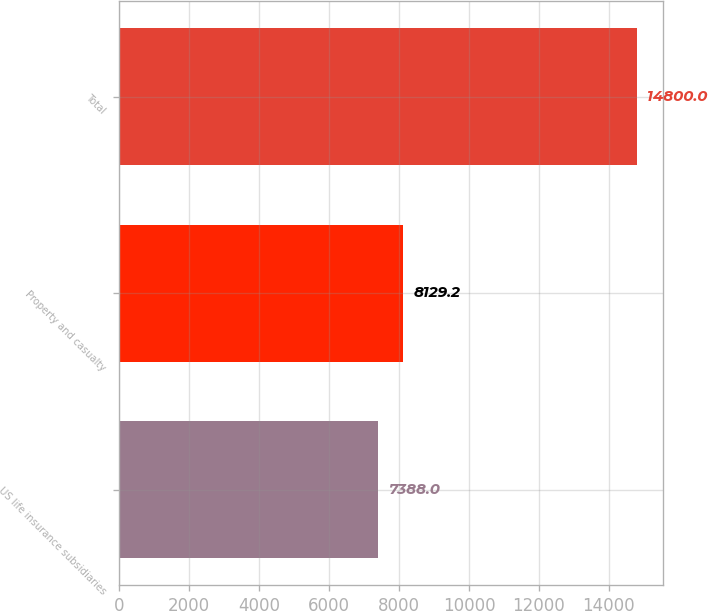<chart> <loc_0><loc_0><loc_500><loc_500><bar_chart><fcel>US life insurance subsidiaries<fcel>Property and casualty<fcel>Total<nl><fcel>7388<fcel>8129.2<fcel>14800<nl></chart> 